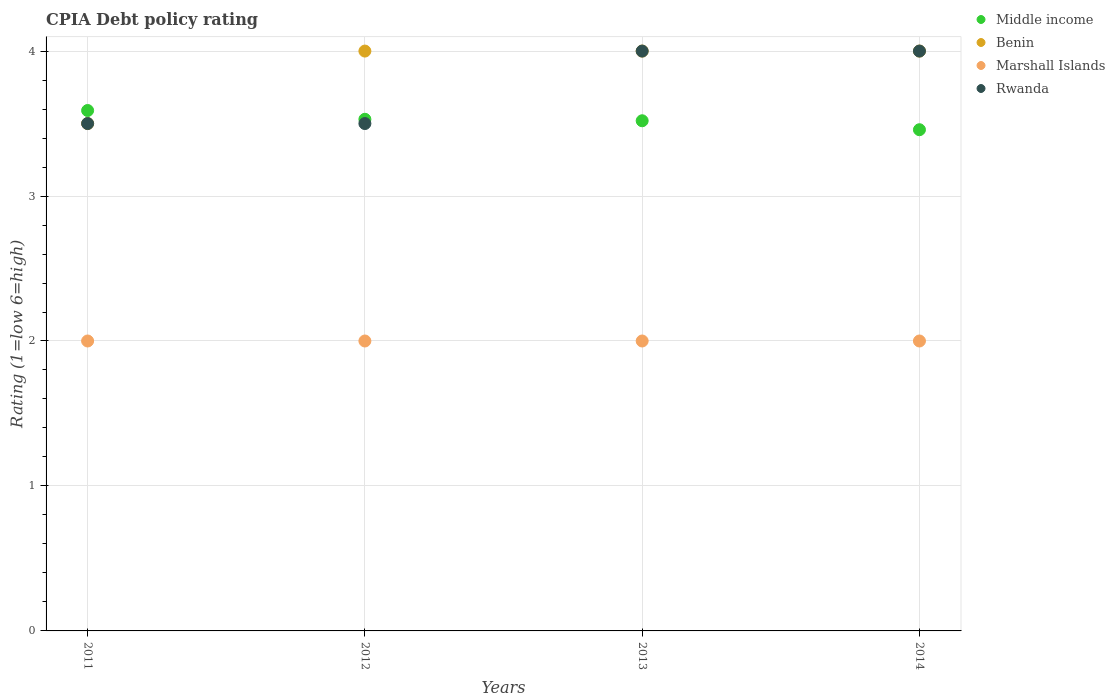How many different coloured dotlines are there?
Offer a terse response. 4. Is the number of dotlines equal to the number of legend labels?
Provide a succinct answer. Yes. What is the CPIA rating in Middle income in 2013?
Offer a very short reply. 3.52. Across all years, what is the maximum CPIA rating in Middle income?
Make the answer very short. 3.59. Across all years, what is the minimum CPIA rating in Marshall Islands?
Provide a short and direct response. 2. In which year was the CPIA rating in Rwanda minimum?
Your answer should be compact. 2011. What is the total CPIA rating in Marshall Islands in the graph?
Provide a short and direct response. 8. What is the difference between the CPIA rating in Marshall Islands in 2013 and the CPIA rating in Benin in 2012?
Give a very brief answer. -2. What is the average CPIA rating in Rwanda per year?
Provide a short and direct response. 3.75. In the year 2014, what is the difference between the CPIA rating in Rwanda and CPIA rating in Marshall Islands?
Your response must be concise. 2. In how many years, is the CPIA rating in Benin greater than 2.2?
Ensure brevity in your answer.  4. What is the difference between the highest and the lowest CPIA rating in Middle income?
Your answer should be compact. 0.13. In how many years, is the CPIA rating in Rwanda greater than the average CPIA rating in Rwanda taken over all years?
Keep it short and to the point. 2. Is the sum of the CPIA rating in Middle income in 2011 and 2014 greater than the maximum CPIA rating in Rwanda across all years?
Your answer should be very brief. Yes. Is it the case that in every year, the sum of the CPIA rating in Marshall Islands and CPIA rating in Rwanda  is greater than the sum of CPIA rating in Middle income and CPIA rating in Benin?
Your response must be concise. Yes. Does the CPIA rating in Marshall Islands monotonically increase over the years?
Your answer should be very brief. No. Is the CPIA rating in Marshall Islands strictly less than the CPIA rating in Benin over the years?
Offer a very short reply. Yes. How many years are there in the graph?
Make the answer very short. 4. What is the difference between two consecutive major ticks on the Y-axis?
Make the answer very short. 1. Does the graph contain any zero values?
Ensure brevity in your answer.  No. Does the graph contain grids?
Ensure brevity in your answer.  Yes. How many legend labels are there?
Your answer should be compact. 4. What is the title of the graph?
Offer a very short reply. CPIA Debt policy rating. What is the label or title of the X-axis?
Provide a succinct answer. Years. What is the label or title of the Y-axis?
Your answer should be very brief. Rating (1=low 6=high). What is the Rating (1=low 6=high) of Middle income in 2011?
Offer a very short reply. 3.59. What is the Rating (1=low 6=high) in Middle income in 2012?
Your answer should be compact. 3.53. What is the Rating (1=low 6=high) of Marshall Islands in 2012?
Your answer should be very brief. 2. What is the Rating (1=low 6=high) in Middle income in 2013?
Offer a very short reply. 3.52. What is the Rating (1=low 6=high) in Benin in 2013?
Make the answer very short. 4. What is the Rating (1=low 6=high) of Middle income in 2014?
Ensure brevity in your answer.  3.46. What is the Rating (1=low 6=high) in Marshall Islands in 2014?
Ensure brevity in your answer.  2. Across all years, what is the maximum Rating (1=low 6=high) of Middle income?
Provide a succinct answer. 3.59. Across all years, what is the maximum Rating (1=low 6=high) in Benin?
Your answer should be very brief. 4. Across all years, what is the maximum Rating (1=low 6=high) of Rwanda?
Your answer should be compact. 4. Across all years, what is the minimum Rating (1=low 6=high) in Middle income?
Your response must be concise. 3.46. Across all years, what is the minimum Rating (1=low 6=high) in Benin?
Provide a short and direct response. 3.5. Across all years, what is the minimum Rating (1=low 6=high) of Rwanda?
Make the answer very short. 3.5. What is the total Rating (1=low 6=high) of Middle income in the graph?
Offer a terse response. 14.1. What is the total Rating (1=low 6=high) of Benin in the graph?
Provide a succinct answer. 15.5. What is the total Rating (1=low 6=high) in Marshall Islands in the graph?
Make the answer very short. 8. What is the difference between the Rating (1=low 6=high) in Middle income in 2011 and that in 2012?
Offer a terse response. 0.06. What is the difference between the Rating (1=low 6=high) of Benin in 2011 and that in 2012?
Your answer should be very brief. -0.5. What is the difference between the Rating (1=low 6=high) in Middle income in 2011 and that in 2013?
Offer a terse response. 0.07. What is the difference between the Rating (1=low 6=high) in Benin in 2011 and that in 2013?
Make the answer very short. -0.5. What is the difference between the Rating (1=low 6=high) in Middle income in 2011 and that in 2014?
Keep it short and to the point. 0.13. What is the difference between the Rating (1=low 6=high) in Benin in 2011 and that in 2014?
Give a very brief answer. -0.5. What is the difference between the Rating (1=low 6=high) of Middle income in 2012 and that in 2013?
Provide a short and direct response. 0.01. What is the difference between the Rating (1=low 6=high) in Marshall Islands in 2012 and that in 2013?
Keep it short and to the point. 0. What is the difference between the Rating (1=low 6=high) in Middle income in 2012 and that in 2014?
Give a very brief answer. 0.07. What is the difference between the Rating (1=low 6=high) of Benin in 2012 and that in 2014?
Your answer should be compact. 0. What is the difference between the Rating (1=low 6=high) in Marshall Islands in 2012 and that in 2014?
Offer a very short reply. 0. What is the difference between the Rating (1=low 6=high) of Middle income in 2013 and that in 2014?
Make the answer very short. 0.06. What is the difference between the Rating (1=low 6=high) in Benin in 2013 and that in 2014?
Your answer should be very brief. 0. What is the difference between the Rating (1=low 6=high) of Marshall Islands in 2013 and that in 2014?
Offer a very short reply. 0. What is the difference between the Rating (1=low 6=high) of Rwanda in 2013 and that in 2014?
Provide a short and direct response. 0. What is the difference between the Rating (1=low 6=high) of Middle income in 2011 and the Rating (1=low 6=high) of Benin in 2012?
Provide a succinct answer. -0.41. What is the difference between the Rating (1=low 6=high) of Middle income in 2011 and the Rating (1=low 6=high) of Marshall Islands in 2012?
Offer a terse response. 1.59. What is the difference between the Rating (1=low 6=high) of Middle income in 2011 and the Rating (1=low 6=high) of Rwanda in 2012?
Offer a terse response. 0.09. What is the difference between the Rating (1=low 6=high) of Marshall Islands in 2011 and the Rating (1=low 6=high) of Rwanda in 2012?
Make the answer very short. -1.5. What is the difference between the Rating (1=low 6=high) in Middle income in 2011 and the Rating (1=low 6=high) in Benin in 2013?
Your answer should be compact. -0.41. What is the difference between the Rating (1=low 6=high) of Middle income in 2011 and the Rating (1=low 6=high) of Marshall Islands in 2013?
Provide a short and direct response. 1.59. What is the difference between the Rating (1=low 6=high) in Middle income in 2011 and the Rating (1=low 6=high) in Rwanda in 2013?
Your answer should be compact. -0.41. What is the difference between the Rating (1=low 6=high) of Benin in 2011 and the Rating (1=low 6=high) of Marshall Islands in 2013?
Keep it short and to the point. 1.5. What is the difference between the Rating (1=low 6=high) of Benin in 2011 and the Rating (1=low 6=high) of Rwanda in 2013?
Offer a terse response. -0.5. What is the difference between the Rating (1=low 6=high) of Marshall Islands in 2011 and the Rating (1=low 6=high) of Rwanda in 2013?
Offer a terse response. -2. What is the difference between the Rating (1=low 6=high) in Middle income in 2011 and the Rating (1=low 6=high) in Benin in 2014?
Provide a short and direct response. -0.41. What is the difference between the Rating (1=low 6=high) in Middle income in 2011 and the Rating (1=low 6=high) in Marshall Islands in 2014?
Provide a succinct answer. 1.59. What is the difference between the Rating (1=low 6=high) of Middle income in 2011 and the Rating (1=low 6=high) of Rwanda in 2014?
Offer a very short reply. -0.41. What is the difference between the Rating (1=low 6=high) of Benin in 2011 and the Rating (1=low 6=high) of Rwanda in 2014?
Keep it short and to the point. -0.5. What is the difference between the Rating (1=low 6=high) in Marshall Islands in 2011 and the Rating (1=low 6=high) in Rwanda in 2014?
Your response must be concise. -2. What is the difference between the Rating (1=low 6=high) in Middle income in 2012 and the Rating (1=low 6=high) in Benin in 2013?
Provide a succinct answer. -0.47. What is the difference between the Rating (1=low 6=high) in Middle income in 2012 and the Rating (1=low 6=high) in Marshall Islands in 2013?
Give a very brief answer. 1.53. What is the difference between the Rating (1=low 6=high) of Middle income in 2012 and the Rating (1=low 6=high) of Rwanda in 2013?
Ensure brevity in your answer.  -0.47. What is the difference between the Rating (1=low 6=high) in Benin in 2012 and the Rating (1=low 6=high) in Rwanda in 2013?
Give a very brief answer. 0. What is the difference between the Rating (1=low 6=high) of Marshall Islands in 2012 and the Rating (1=low 6=high) of Rwanda in 2013?
Your response must be concise. -2. What is the difference between the Rating (1=low 6=high) in Middle income in 2012 and the Rating (1=low 6=high) in Benin in 2014?
Offer a very short reply. -0.47. What is the difference between the Rating (1=low 6=high) of Middle income in 2012 and the Rating (1=low 6=high) of Marshall Islands in 2014?
Your answer should be very brief. 1.53. What is the difference between the Rating (1=low 6=high) in Middle income in 2012 and the Rating (1=low 6=high) in Rwanda in 2014?
Your answer should be very brief. -0.47. What is the difference between the Rating (1=low 6=high) in Benin in 2012 and the Rating (1=low 6=high) in Marshall Islands in 2014?
Offer a terse response. 2. What is the difference between the Rating (1=low 6=high) of Benin in 2012 and the Rating (1=low 6=high) of Rwanda in 2014?
Keep it short and to the point. 0. What is the difference between the Rating (1=low 6=high) of Middle income in 2013 and the Rating (1=low 6=high) of Benin in 2014?
Your response must be concise. -0.48. What is the difference between the Rating (1=low 6=high) in Middle income in 2013 and the Rating (1=low 6=high) in Marshall Islands in 2014?
Provide a short and direct response. 1.52. What is the difference between the Rating (1=low 6=high) of Middle income in 2013 and the Rating (1=low 6=high) of Rwanda in 2014?
Offer a very short reply. -0.48. What is the difference between the Rating (1=low 6=high) of Marshall Islands in 2013 and the Rating (1=low 6=high) of Rwanda in 2014?
Give a very brief answer. -2. What is the average Rating (1=low 6=high) of Middle income per year?
Provide a short and direct response. 3.52. What is the average Rating (1=low 6=high) in Benin per year?
Keep it short and to the point. 3.88. What is the average Rating (1=low 6=high) of Marshall Islands per year?
Offer a terse response. 2. What is the average Rating (1=low 6=high) of Rwanda per year?
Ensure brevity in your answer.  3.75. In the year 2011, what is the difference between the Rating (1=low 6=high) in Middle income and Rating (1=low 6=high) in Benin?
Provide a short and direct response. 0.09. In the year 2011, what is the difference between the Rating (1=low 6=high) in Middle income and Rating (1=low 6=high) in Marshall Islands?
Provide a succinct answer. 1.59. In the year 2011, what is the difference between the Rating (1=low 6=high) in Middle income and Rating (1=low 6=high) in Rwanda?
Ensure brevity in your answer.  0.09. In the year 2011, what is the difference between the Rating (1=low 6=high) of Benin and Rating (1=low 6=high) of Marshall Islands?
Ensure brevity in your answer.  1.5. In the year 2011, what is the difference between the Rating (1=low 6=high) of Marshall Islands and Rating (1=low 6=high) of Rwanda?
Your answer should be very brief. -1.5. In the year 2012, what is the difference between the Rating (1=low 6=high) in Middle income and Rating (1=low 6=high) in Benin?
Provide a succinct answer. -0.47. In the year 2012, what is the difference between the Rating (1=low 6=high) of Middle income and Rating (1=low 6=high) of Marshall Islands?
Offer a terse response. 1.53. In the year 2012, what is the difference between the Rating (1=low 6=high) in Middle income and Rating (1=low 6=high) in Rwanda?
Your response must be concise. 0.03. In the year 2012, what is the difference between the Rating (1=low 6=high) in Benin and Rating (1=low 6=high) in Rwanda?
Your answer should be compact. 0.5. In the year 2013, what is the difference between the Rating (1=low 6=high) of Middle income and Rating (1=low 6=high) of Benin?
Make the answer very short. -0.48. In the year 2013, what is the difference between the Rating (1=low 6=high) in Middle income and Rating (1=low 6=high) in Marshall Islands?
Offer a terse response. 1.52. In the year 2013, what is the difference between the Rating (1=low 6=high) in Middle income and Rating (1=low 6=high) in Rwanda?
Provide a succinct answer. -0.48. In the year 2013, what is the difference between the Rating (1=low 6=high) of Benin and Rating (1=low 6=high) of Rwanda?
Make the answer very short. 0. In the year 2014, what is the difference between the Rating (1=low 6=high) in Middle income and Rating (1=low 6=high) in Benin?
Your answer should be very brief. -0.54. In the year 2014, what is the difference between the Rating (1=low 6=high) of Middle income and Rating (1=low 6=high) of Marshall Islands?
Make the answer very short. 1.46. In the year 2014, what is the difference between the Rating (1=low 6=high) in Middle income and Rating (1=low 6=high) in Rwanda?
Keep it short and to the point. -0.54. What is the ratio of the Rating (1=low 6=high) of Middle income in 2011 to that in 2012?
Offer a terse response. 1.02. What is the ratio of the Rating (1=low 6=high) in Rwanda in 2011 to that in 2012?
Offer a very short reply. 1. What is the ratio of the Rating (1=low 6=high) of Middle income in 2011 to that in 2013?
Keep it short and to the point. 1.02. What is the ratio of the Rating (1=low 6=high) of Marshall Islands in 2011 to that in 2013?
Your response must be concise. 1. What is the ratio of the Rating (1=low 6=high) in Rwanda in 2011 to that in 2013?
Give a very brief answer. 0.88. What is the ratio of the Rating (1=low 6=high) in Middle income in 2011 to that in 2014?
Offer a terse response. 1.04. What is the ratio of the Rating (1=low 6=high) in Benin in 2011 to that in 2014?
Make the answer very short. 0.88. What is the ratio of the Rating (1=low 6=high) in Marshall Islands in 2011 to that in 2014?
Provide a succinct answer. 1. What is the ratio of the Rating (1=low 6=high) in Rwanda in 2011 to that in 2014?
Offer a very short reply. 0.88. What is the ratio of the Rating (1=low 6=high) of Benin in 2012 to that in 2013?
Provide a short and direct response. 1. What is the ratio of the Rating (1=low 6=high) in Marshall Islands in 2012 to that in 2013?
Your answer should be very brief. 1. What is the ratio of the Rating (1=low 6=high) of Rwanda in 2012 to that in 2013?
Ensure brevity in your answer.  0.88. What is the ratio of the Rating (1=low 6=high) of Middle income in 2012 to that in 2014?
Your response must be concise. 1.02. What is the ratio of the Rating (1=low 6=high) in Marshall Islands in 2012 to that in 2014?
Your response must be concise. 1. What is the ratio of the Rating (1=low 6=high) of Middle income in 2013 to that in 2014?
Provide a short and direct response. 1.02. What is the ratio of the Rating (1=low 6=high) of Benin in 2013 to that in 2014?
Keep it short and to the point. 1. What is the ratio of the Rating (1=low 6=high) of Marshall Islands in 2013 to that in 2014?
Your answer should be very brief. 1. What is the difference between the highest and the second highest Rating (1=low 6=high) of Middle income?
Your answer should be compact. 0.06. What is the difference between the highest and the second highest Rating (1=low 6=high) in Benin?
Your answer should be very brief. 0. What is the difference between the highest and the second highest Rating (1=low 6=high) of Marshall Islands?
Ensure brevity in your answer.  0. What is the difference between the highest and the second highest Rating (1=low 6=high) in Rwanda?
Your response must be concise. 0. What is the difference between the highest and the lowest Rating (1=low 6=high) in Middle income?
Keep it short and to the point. 0.13. What is the difference between the highest and the lowest Rating (1=low 6=high) in Benin?
Give a very brief answer. 0.5. What is the difference between the highest and the lowest Rating (1=low 6=high) of Rwanda?
Your answer should be compact. 0.5. 